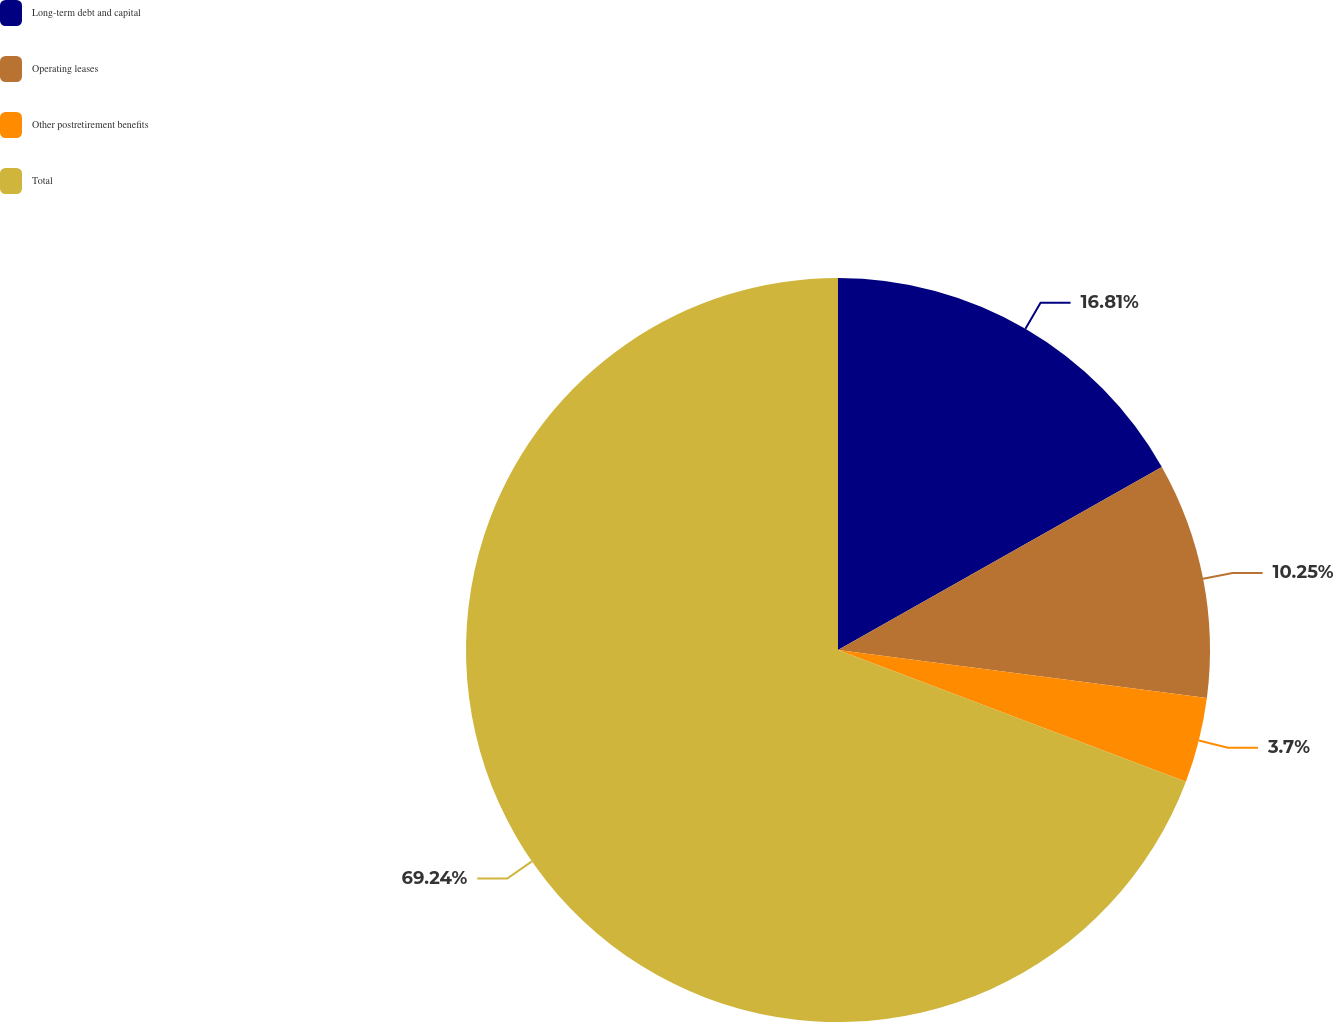<chart> <loc_0><loc_0><loc_500><loc_500><pie_chart><fcel>Long-term debt and capital<fcel>Operating leases<fcel>Other postretirement benefits<fcel>Total<nl><fcel>16.81%<fcel>10.25%<fcel>3.7%<fcel>69.24%<nl></chart> 